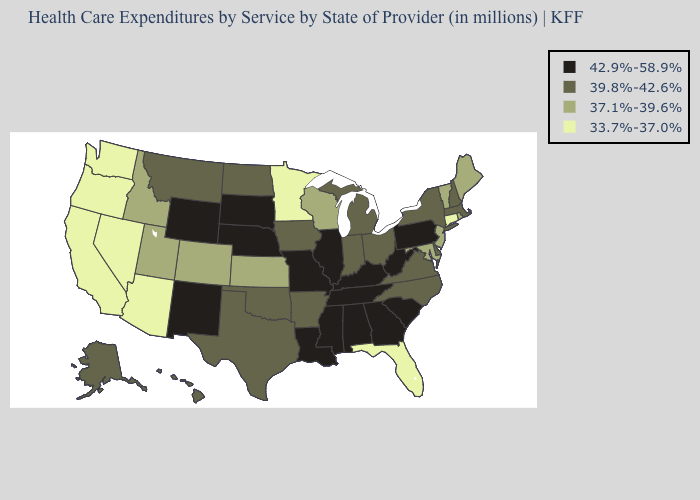What is the lowest value in states that border Oregon?
Write a very short answer. 33.7%-37.0%. Name the states that have a value in the range 39.8%-42.6%?
Answer briefly. Alaska, Arkansas, Delaware, Hawaii, Indiana, Iowa, Massachusetts, Michigan, Montana, New Hampshire, New York, North Carolina, North Dakota, Ohio, Oklahoma, Texas, Virginia. What is the value of New Jersey?
Give a very brief answer. 37.1%-39.6%. Name the states that have a value in the range 37.1%-39.6%?
Write a very short answer. Colorado, Idaho, Kansas, Maine, Maryland, New Jersey, Rhode Island, Utah, Vermont, Wisconsin. Does Illinois have the highest value in the USA?
Concise answer only. Yes. Does Maine have the highest value in the Northeast?
Concise answer only. No. What is the lowest value in states that border Wyoming?
Be succinct. 37.1%-39.6%. Which states have the highest value in the USA?
Answer briefly. Alabama, Georgia, Illinois, Kentucky, Louisiana, Mississippi, Missouri, Nebraska, New Mexico, Pennsylvania, South Carolina, South Dakota, Tennessee, West Virginia, Wyoming. What is the value of Iowa?
Keep it brief. 39.8%-42.6%. Name the states that have a value in the range 42.9%-58.9%?
Give a very brief answer. Alabama, Georgia, Illinois, Kentucky, Louisiana, Mississippi, Missouri, Nebraska, New Mexico, Pennsylvania, South Carolina, South Dakota, Tennessee, West Virginia, Wyoming. Does the first symbol in the legend represent the smallest category?
Give a very brief answer. No. Does Illinois have a lower value than Utah?
Quick response, please. No. Does Arizona have the same value as Oregon?
Answer briefly. Yes. Which states hav the highest value in the West?
Be succinct. New Mexico, Wyoming. 